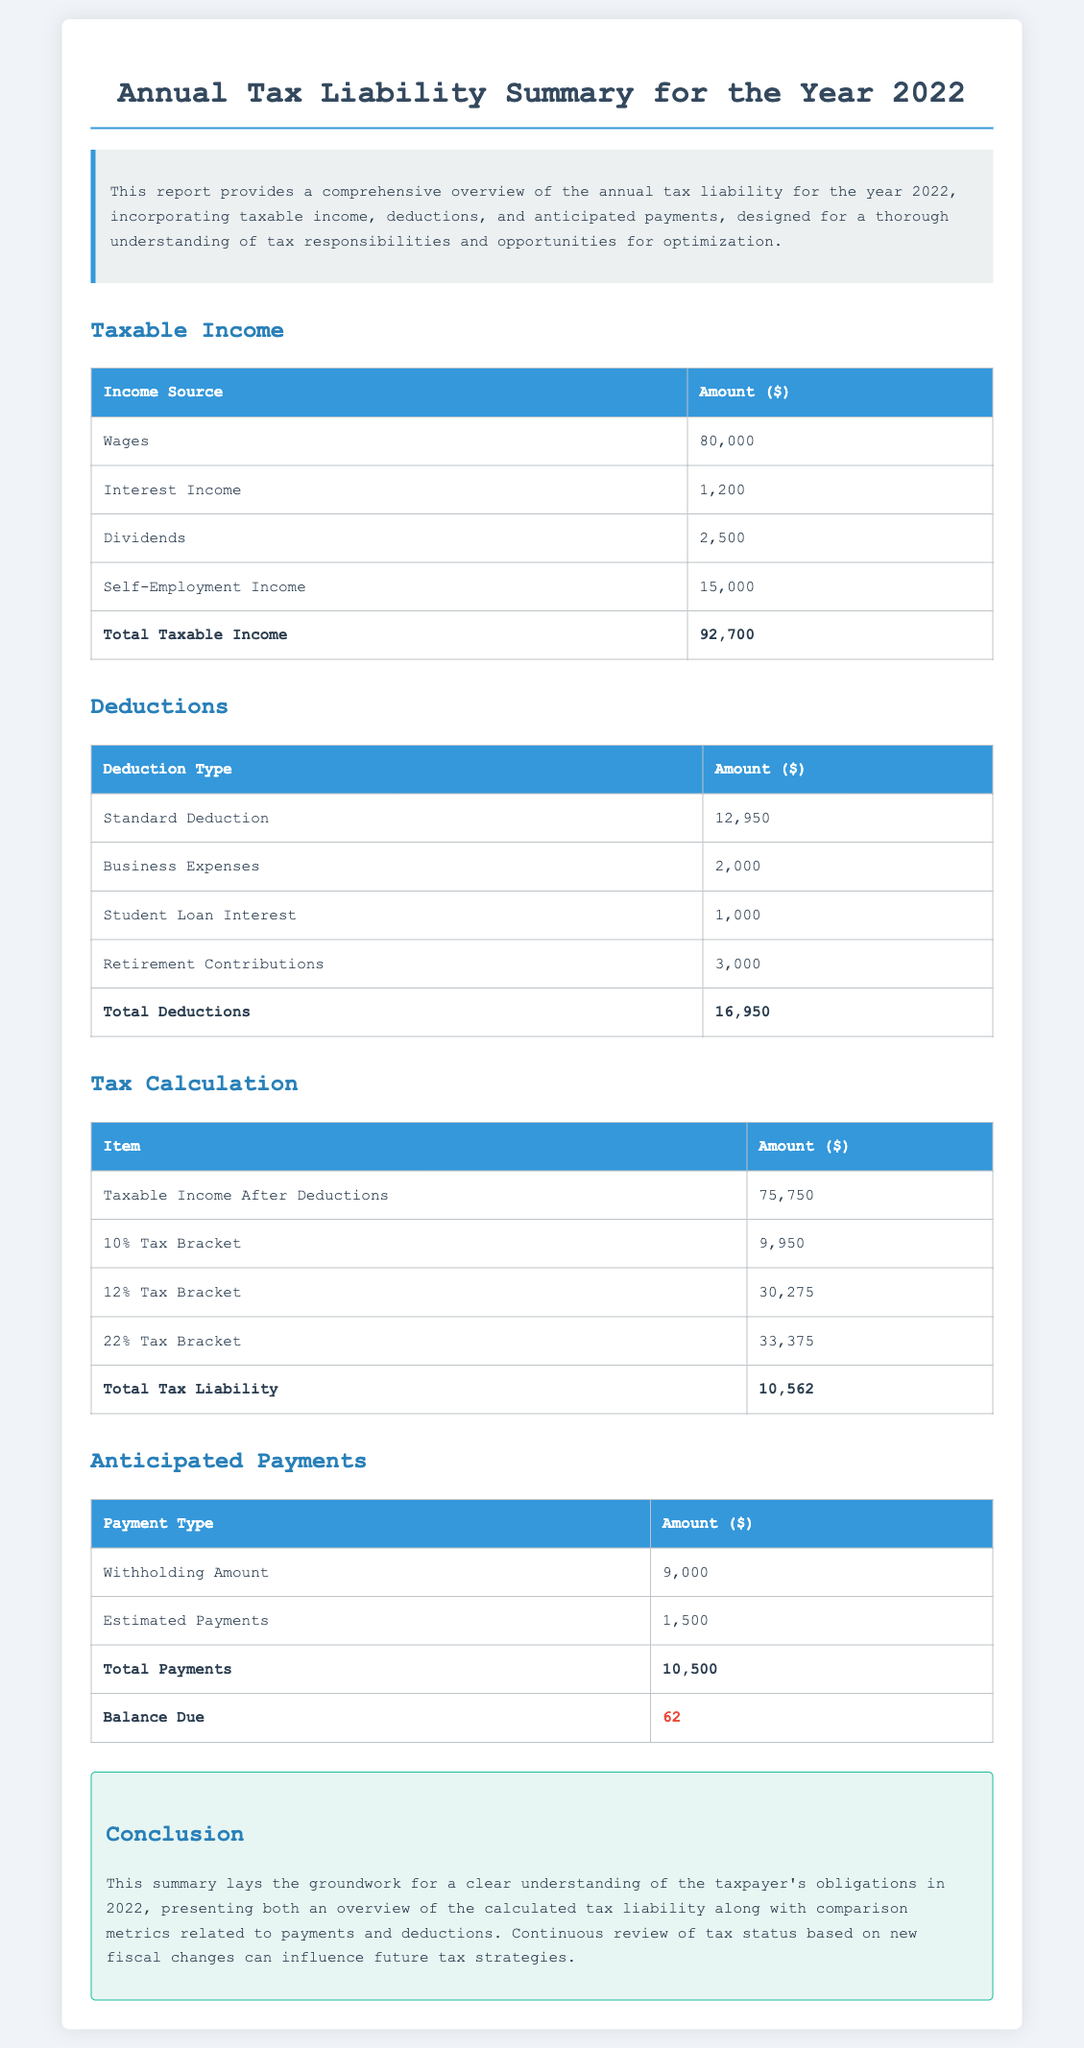What is the total taxable income? The total taxable income is calculated by summing all income sources listed in the document, which totals $80,000 + $1,200 + $2,500 + $15,000 = $92,700.
Answer: $92,700 What is the amount for the standard deduction? The standard deduction is specifically listed in the deductions table as $12,950.
Answer: $12,950 What is the total deductions amount? The total deductions are derived from the sum of all deduction types listed, which is $12,950 + $2,000 + $1,000 + $3,000 = $16,950.
Answer: $16,950 What is the total tax liability for the year 2022? The total tax liability is presented at the end of the tax calculation table as $10,562.
Answer: $10,562 What is the balance due after payments? The balance due is the final line in the anticipated payments table, calculated as the total tax liability minus total payments, which amounts to $62.
Answer: 62 What is the amount of withholding payments? The withholding amount is clearly stated in the anticipated payments section as $9,000.
Answer: $9,000 How much are estimated payments? The estimated payments are given in the anticipated payments table as $1,500.
Answer: $1,500 What percentage tax bracket is applied to the first $9,950? The first $9,950 is taxed at the 10% tax bracket.
Answer: 10% What type of report is this document? The document is summarized as an Annual Tax Liability Summary.
Answer: Annual Tax Liability Summary 